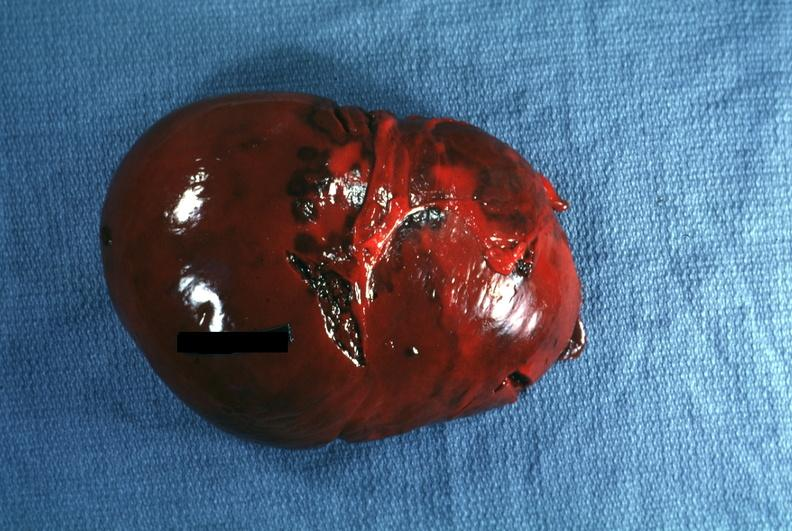what is present?
Answer the question using a single word or phrase. Hematologic 